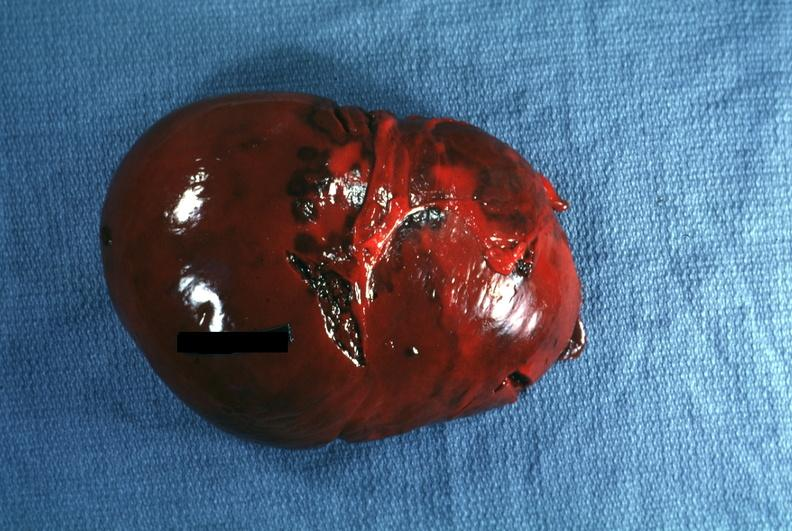what is present?
Answer the question using a single word or phrase. Hematologic 